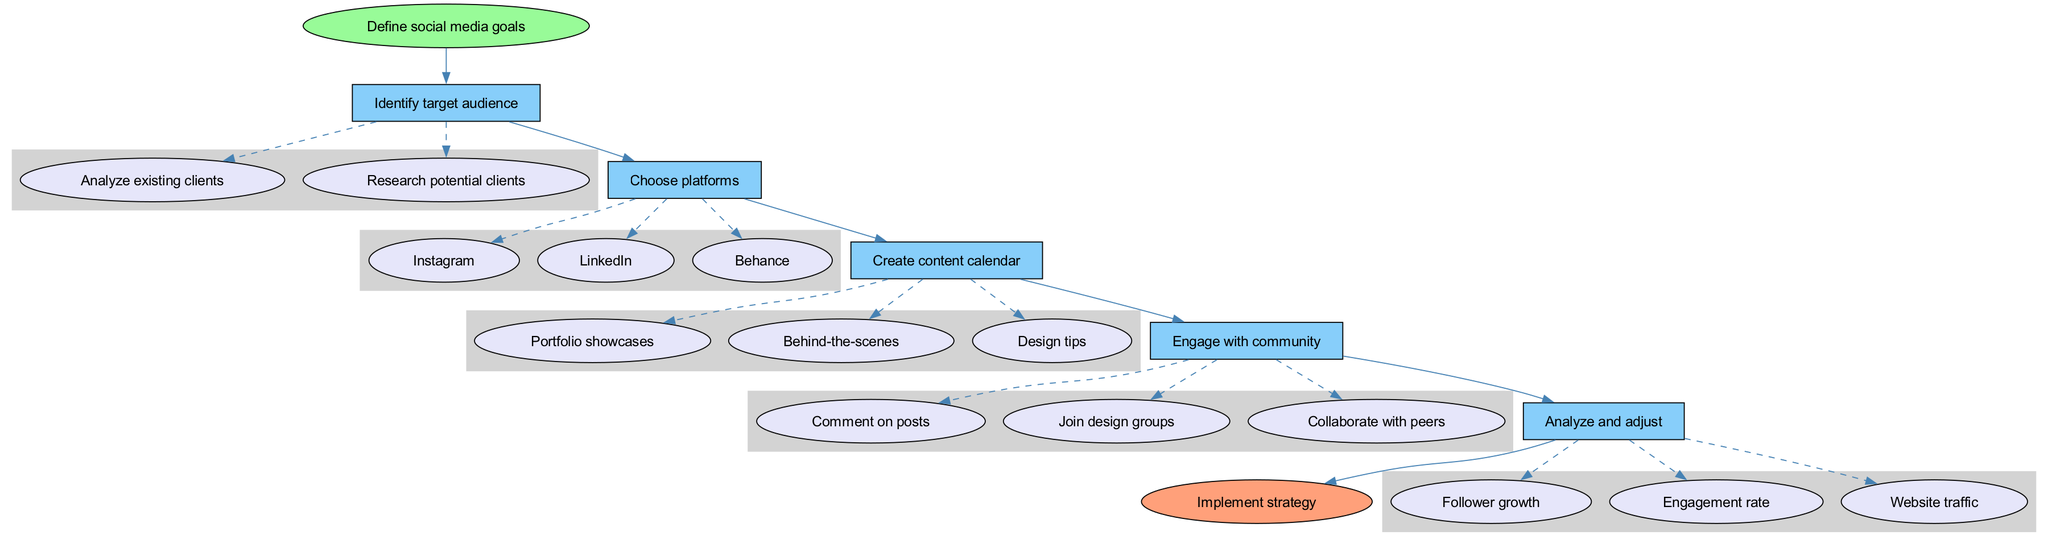What is the first step in the diagram? The first step is labeled as "Define social media goals." This is indicated as the starting point of the flow chart, showing the initial action to take in developing a social media marketing strategy.
Answer: Define social media goals How many steps are there in total? Counting the main steps listed in the diagram, there are five steps that outline the process of creating a social media marketing strategy.
Answer: Five Which platforms are suggested for choosing? The diagram suggests three platforms: Instagram, LinkedIn, and Behance. These platforms are highlighted as options in the "Choose platforms" step and are visually connected to it.
Answer: Instagram, LinkedIn, Behance What action is listed under "Engage with community"? One of the actions listed under "Engage with community" is "Comment on posts." This is one of the activities participants should focus on to increase engagement in the community.
Answer: Comment on posts What is the final action to take after completing the steps? The final action indicated in the diagram is "Implement strategy." This is the conclusion of the flow chart, showing that after going through the previous steps, the strategy should be put into action.
Answer: Implement strategy What are the metrics mentioned for analyzing performance? The diagram lists three metrics for analysis: "Follower growth," "Engagement rate," and "Website traffic." These metrics are essential for assessing the effectiveness of the implemented strategy.
Answer: Follower growth, Engagement rate, Website traffic Which node is connected to the starting point? The first step, "Identify target audience," is directly connected to the starting point "Define social media goals." This shows that after defining goals, the next action is to identify the target audience.
Answer: Identify target audience How are the substeps for "Identify target audience" represented? The substeps under "Identify target audience" are represented as ovals connected to the step by dashed lines, indicating that they elaborate on the main step's action.
Answer: Ovals with dashed lines What is the relationship between "Analyze and adjust" and "Implement strategy"? "Analyze and adjust" is a step that precedes "Implement strategy," indicating that analysis should happen before final implementation. This relationship indicates a flow where the strategy is monitored and adjusted prior to full implementation.
Answer: Precedes 